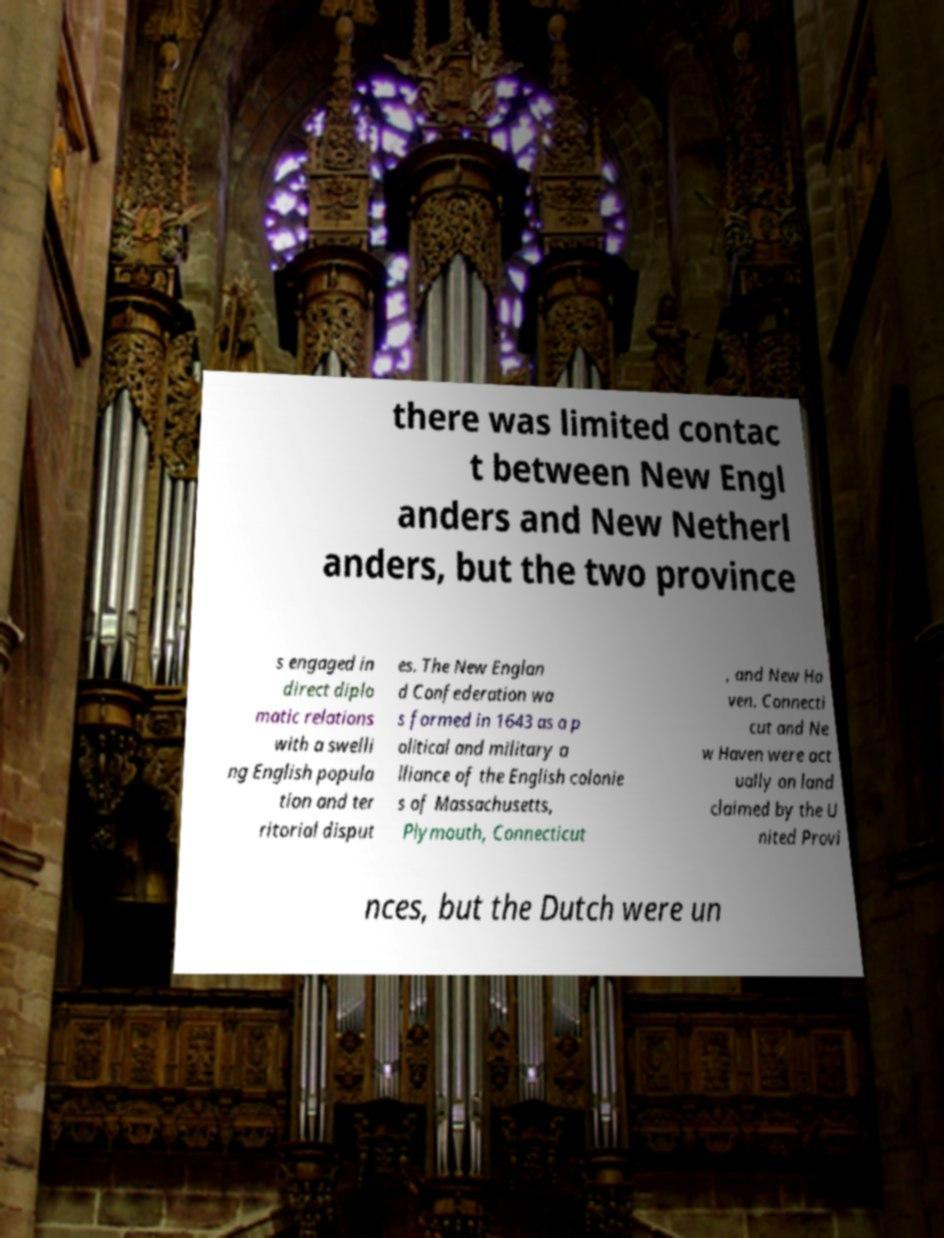Can you read and provide the text displayed in the image?This photo seems to have some interesting text. Can you extract and type it out for me? there was limited contac t between New Engl anders and New Netherl anders, but the two province s engaged in direct diplo matic relations with a swelli ng English popula tion and ter ritorial disput es. The New Englan d Confederation wa s formed in 1643 as a p olitical and military a lliance of the English colonie s of Massachusetts, Plymouth, Connecticut , and New Ha ven. Connecti cut and Ne w Haven were act ually on land claimed by the U nited Provi nces, but the Dutch were un 